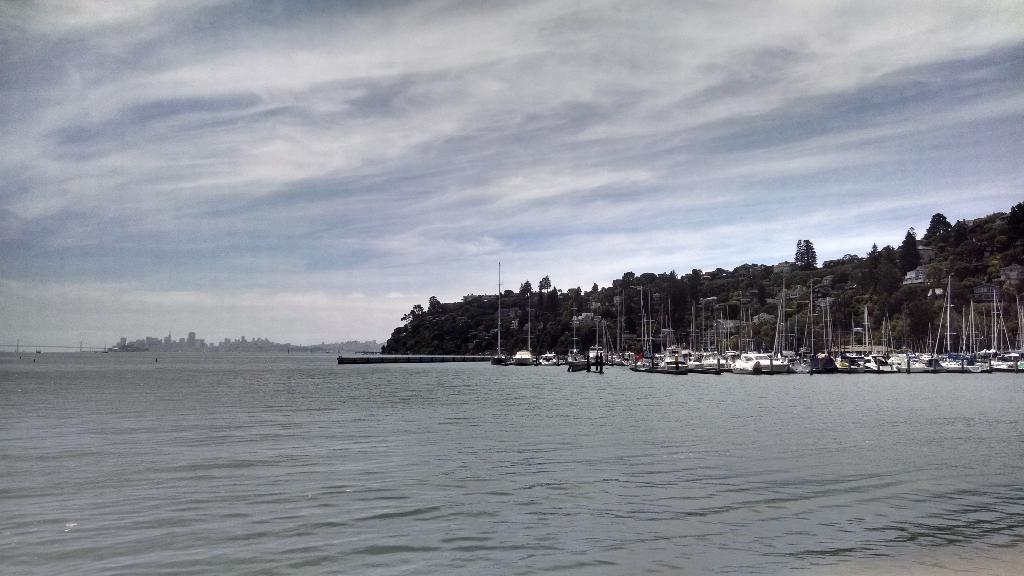What can be seen on the right side of the image? There are ships on the right side of the image. What is visible at the bottom of the image? There is a sea visible at the bottom of the image. What is located in the background of the image? There is a hill in the background of the image, and the sky is also visible. How many chickens are standing on the hill in the image? There are no chickens present in the image; it features ships, a sea, a hill, and the sky. What type of blade is being used by the ship in the image? There is no blade visible in the image. 